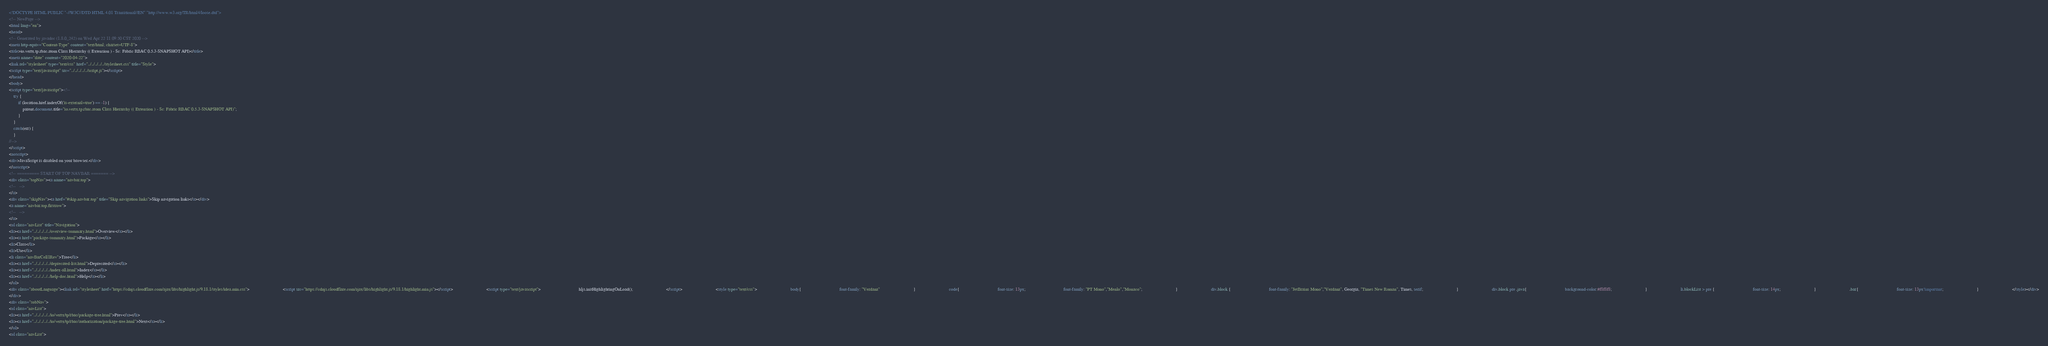Convert code to text. <code><loc_0><loc_0><loc_500><loc_500><_HTML_><!DOCTYPE HTML PUBLIC "-//W3C//DTD HTML 4.01 Transitional//EN" "http://www.w3.org/TR/html4/loose.dtd">
<!-- NewPage -->
<html lang="en">
<head>
<!-- Generated by javadoc (1.8.0_242) on Wed Apr 22 11:09:50 CST 2020 -->
<meta http-equiv="Content-Type" content="text/html; charset=UTF-8">
<title>io.vertx.tp.rbac.atom Class Hierarchy (( Extension ) - Sc: Fabric RBAC 0.5.3-SNAPSHOT API)</title>
<meta name="date" content="2020-04-22">
<link rel="stylesheet" type="text/css" href="../../../../../stylesheet.css" title="Style">
<script type="text/javascript" src="../../../../../script.js"></script>
</head>
<body>
<script type="text/javascript"><!--
    try {
        if (location.href.indexOf('is-external=true') == -1) {
            parent.document.title="io.vertx.tp.rbac.atom Class Hierarchy (( Extension ) - Sc: Fabric RBAC 0.5.3-SNAPSHOT API)";
        }
    }
    catch(err) {
    }
//-->
</script>
<noscript>
<div>JavaScript is disabled on your browser.</div>
</noscript>
<!-- ========= START OF TOP NAVBAR ======= -->
<div class="topNav"><a name="navbar.top">
<!--   -->
</a>
<div class="skipNav"><a href="#skip.navbar.top" title="Skip navigation links">Skip navigation links</a></div>
<a name="navbar.top.firstrow">
<!--   -->
</a>
<ul class="navList" title="Navigation">
<li><a href="../../../../../overview-summary.html">Overview</a></li>
<li><a href="package-summary.html">Package</a></li>
<li>Class</li>
<li>Use</li>
<li class="navBarCell1Rev">Tree</li>
<li><a href="../../../../../deprecated-list.html">Deprecated</a></li>
<li><a href="../../../../../index-all.html">Index</a></li>
<li><a href="../../../../../help-doc.html">Help</a></li>
</ul>
<div class="aboutLanguage"><link rel="stylesheet" href="https://cdnjs.cloudflare.com/ajax/libs/highlight.js/9.18.1/styles/idea.min.css">                             <script src="https://cdnjs.cloudflare.com/ajax/libs/highlight.js/9.18.1/highlight.min.js"></script>                             <script type="text/javascript">                                 hljs.initHighlightingOnLoad();                             </script>                             <style type="text/css">                             body{                                 font-family: "Verdana"                             }                             code{                                 font-size: 13px;                                 font-family: "PT Mono","Menlo","Monaco";                             }                             div.block {                                 font-family: "JetBrains Mono","Verdana", Georgia, "Times New Roman", Times, serif;                             }                             div.block pre .java{                                 background-color:#f8f8f8;                             }                             li.blockList > pre {                                 font-size: 14px;                             }                             .bar{                                 font-size: 13px!important;                             }                             </style></div>
</div>
<div class="subNav">
<ul class="navList">
<li><a href="../../../../../io/vertx/tp/rbac/package-tree.html">Prev</a></li>
<li><a href="../../../../../io/vertx/tp/rbac/authorization/package-tree.html">Next</a></li>
</ul>
<ul class="navList"></code> 